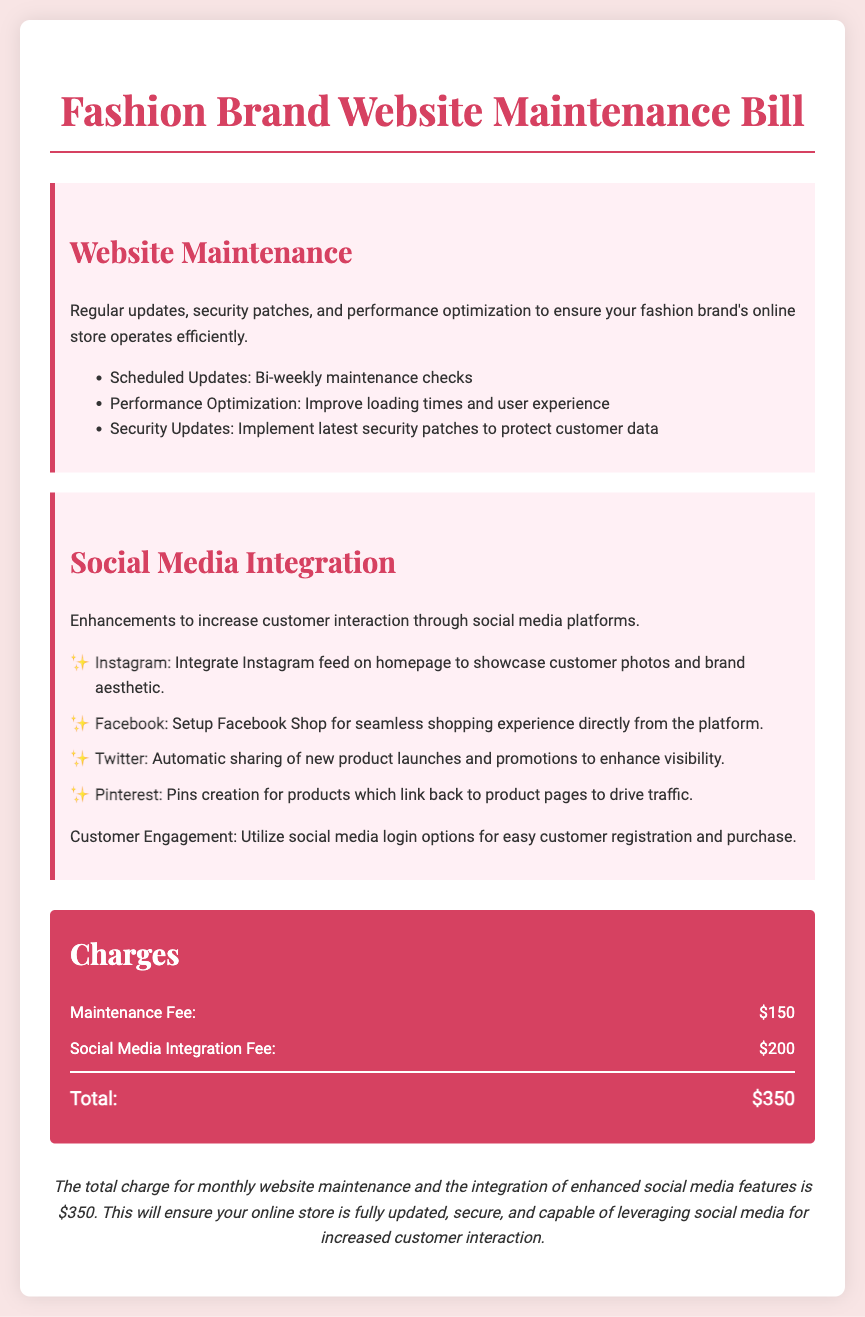What is the total charge for this month's services? The total charge is stated at the end of the billing document, which sums up the maintenance and integration fees.
Answer: $350 How much is the Maintenance Fee? The document specifies the Maintenance Fee amount listed under the Charges section.
Answer: $150 What security updates are included in the website maintenance? The types of security updates are mentioned under the Website Maintenance section, specifically that they involve implementing the latest security patches.
Answer: Latest security patches Which social media platform has an Instagram feed integration? The social media integration section indicates that the Instagram feed is integrated on the homepage for showcasing customer photos.
Answer: Instagram How often are maintenance checks scheduled? The document notes that scheduled updates occur on a bi-weekly basis.
Answer: Bi-weekly What is one way customer engagement is enhanced through social media integrations? The document describes customer engagement improvements, including social media login options for easier registration and purchases.
Answer: Social media login options What is the fee for Social Media Integration? The specific fee for Social Media Integration is listed in the Charges section of the document.
Answer: $200 What type of product promotion is done automatically via Twitter? The document mentions that there is automatic sharing of new product launches and promotions on Twitter.
Answer: New product launches and promotions Which feature links Pinterest pins back to product pages? Under the Social Media Integration section, it states that product pins created for Pinterest will link back to product pages to drive traffic.
Answer: Pins creation for products 